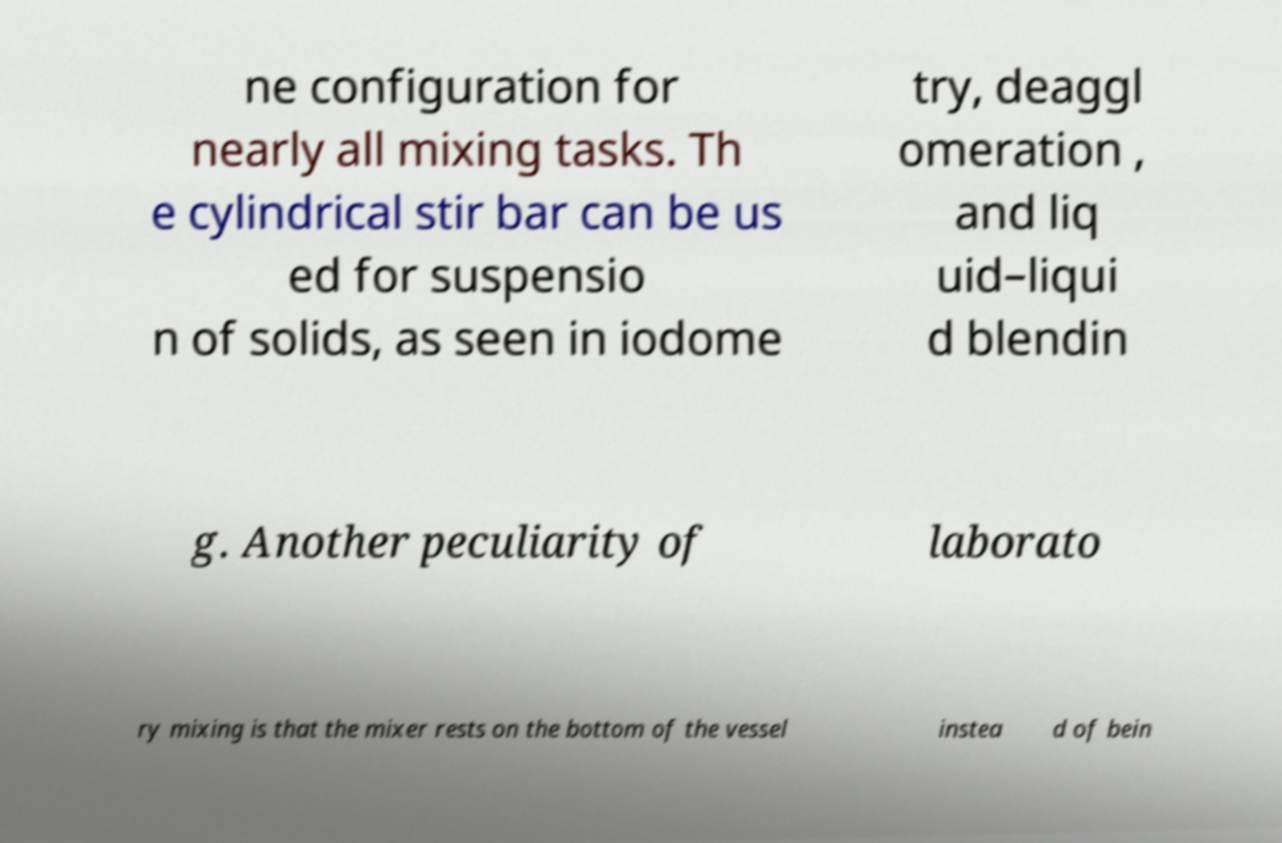Could you extract and type out the text from this image? ne configuration for nearly all mixing tasks. Th e cylindrical stir bar can be us ed for suspensio n of solids, as seen in iodome try, deaggl omeration , and liq uid–liqui d blendin g. Another peculiarity of laborato ry mixing is that the mixer rests on the bottom of the vessel instea d of bein 